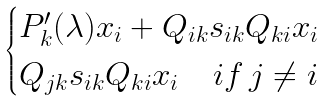<formula> <loc_0><loc_0><loc_500><loc_500>\begin{cases} P ^ { \prime } _ { k } ( \lambda ) x _ { i } + Q _ { i k } s _ { i k } Q _ { k i } x _ { i } \\ Q _ { j k } s _ { i k } Q _ { k i } x _ { i } \quad i f \, j \not = i \\ \end{cases}</formula> 